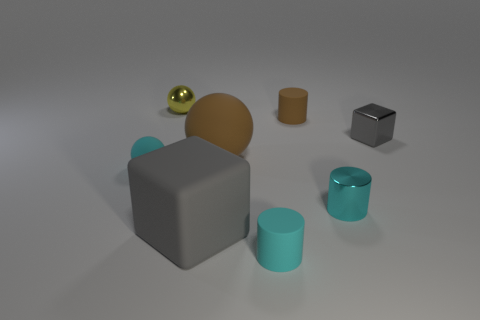Subtract all matte cylinders. How many cylinders are left? 1 Subtract all brown cylinders. How many cylinders are left? 2 Add 1 tiny brown rubber cylinders. How many objects exist? 9 Subtract all gray balls. How many cyan cylinders are left? 2 Subtract all blocks. How many objects are left? 6 Subtract 1 yellow balls. How many objects are left? 7 Subtract 1 balls. How many balls are left? 2 Subtract all brown blocks. Subtract all cyan cylinders. How many blocks are left? 2 Subtract all small brown rubber cylinders. Subtract all big green objects. How many objects are left? 7 Add 6 cyan balls. How many cyan balls are left? 7 